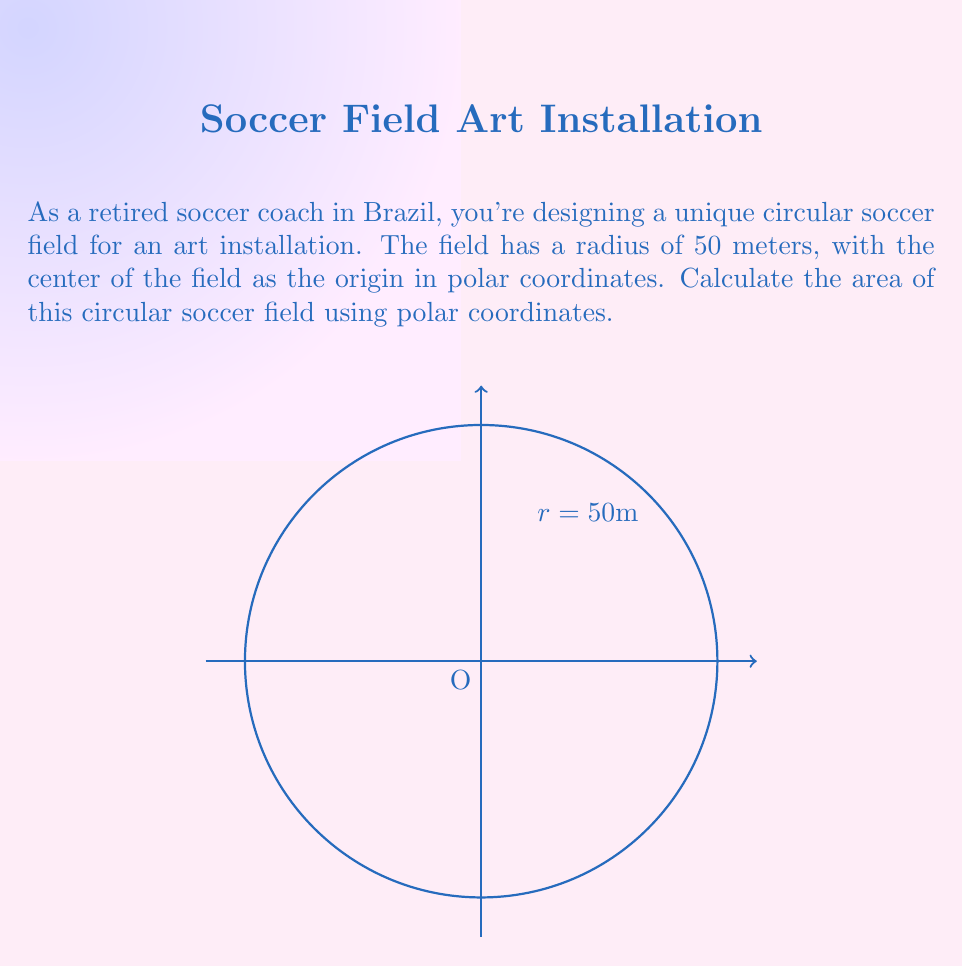What is the answer to this math problem? To calculate the area of a circular region using polar coordinates, we use the formula:

$$ A = \frac{1}{2} \int_0^{2\pi} r^2 d\theta $$

Where $r$ is the radius and $\theta$ is the angle in radians.

For a circle with a constant radius of 50 meters:

1) Substitute $r = 50$ into the formula:
   $$ A = \frac{1}{2} \int_0^{2\pi} 50^2 d\theta $$

2) Simplify the integrand:
   $$ A = \frac{1}{2} \int_0^{2\pi} 2500 d\theta $$

3) Since 2500 is constant, we can take it out of the integral:
   $$ A = \frac{1}{2} \cdot 2500 \int_0^{2\pi} d\theta $$

4) Integrate:
   $$ A = \frac{1}{2} \cdot 2500 \cdot [\theta]_0^{2\pi} = \frac{1}{2} \cdot 2500 \cdot (2\pi - 0) $$

5) Simplify:
   $$ A = 1250 \cdot 2\pi = 2500\pi $$

Therefore, the area of the circular soccer field is $2500\pi$ square meters.
Answer: $2500\pi$ square meters 